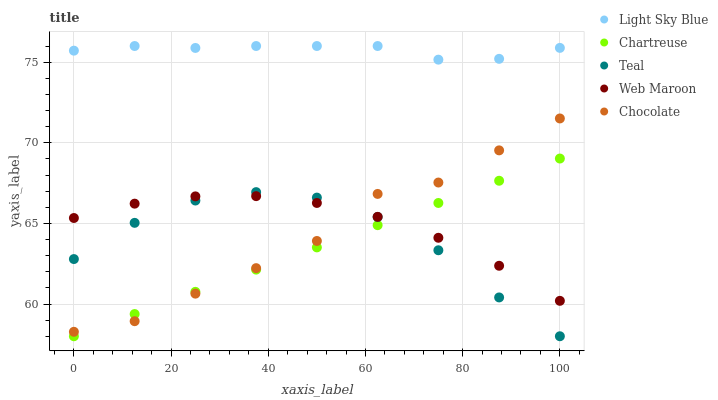Does Chartreuse have the minimum area under the curve?
Answer yes or no. Yes. Does Light Sky Blue have the maximum area under the curve?
Answer yes or no. Yes. Does Web Maroon have the minimum area under the curve?
Answer yes or no. No. Does Web Maroon have the maximum area under the curve?
Answer yes or no. No. Is Chartreuse the smoothest?
Answer yes or no. Yes. Is Chocolate the roughest?
Answer yes or no. Yes. Is Light Sky Blue the smoothest?
Answer yes or no. No. Is Light Sky Blue the roughest?
Answer yes or no. No. Does Chartreuse have the lowest value?
Answer yes or no. Yes. Does Web Maroon have the lowest value?
Answer yes or no. No. Does Light Sky Blue have the highest value?
Answer yes or no. Yes. Does Web Maroon have the highest value?
Answer yes or no. No. Is Teal less than Light Sky Blue?
Answer yes or no. Yes. Is Light Sky Blue greater than Chocolate?
Answer yes or no. Yes. Does Teal intersect Chocolate?
Answer yes or no. Yes. Is Teal less than Chocolate?
Answer yes or no. No. Is Teal greater than Chocolate?
Answer yes or no. No. Does Teal intersect Light Sky Blue?
Answer yes or no. No. 